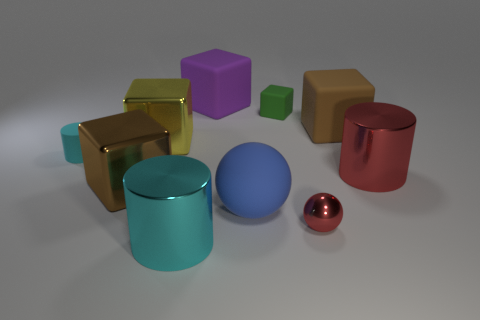Subtract 1 blocks. How many blocks are left? 4 Subtract all green rubber cubes. How many cubes are left? 4 Subtract all green cubes. How many cubes are left? 4 Subtract all red blocks. Subtract all yellow cylinders. How many blocks are left? 5 Subtract all spheres. How many objects are left? 8 Subtract all small gray matte spheres. Subtract all green matte objects. How many objects are left? 9 Add 2 green rubber objects. How many green rubber objects are left? 3 Add 1 red things. How many red things exist? 3 Subtract 1 cyan cylinders. How many objects are left? 9 